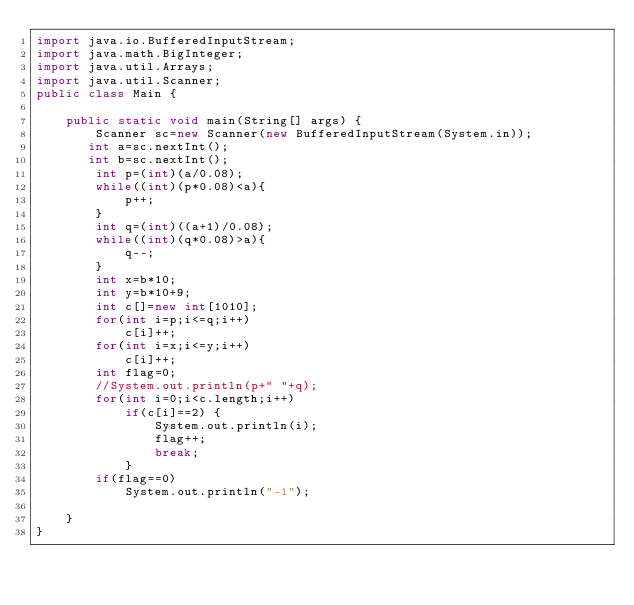Convert code to text. <code><loc_0><loc_0><loc_500><loc_500><_Java_>import java.io.BufferedInputStream;
import java.math.BigInteger;
import java.util.Arrays;
import java.util.Scanner;
public class Main {

    public static void main(String[] args) {
        Scanner sc=new Scanner(new BufferedInputStream(System.in));
       int a=sc.nextInt();
       int b=sc.nextInt();
        int p=(int)(a/0.08);
        while((int)(p*0.08)<a){
            p++;
        }
        int q=(int)((a+1)/0.08);
        while((int)(q*0.08)>a){
            q--;
        }
        int x=b*10;
        int y=b*10+9;
        int c[]=new int[1010];
        for(int i=p;i<=q;i++)
            c[i]++;
        for(int i=x;i<=y;i++)
            c[i]++;
        int flag=0;
        //System.out.println(p+" "+q);
        for(int i=0;i<c.length;i++)
            if(c[i]==2) {
                System.out.println(i);
                flag++;
                break;
            }
        if(flag==0)
            System.out.println("-1");

    }
}



</code> 